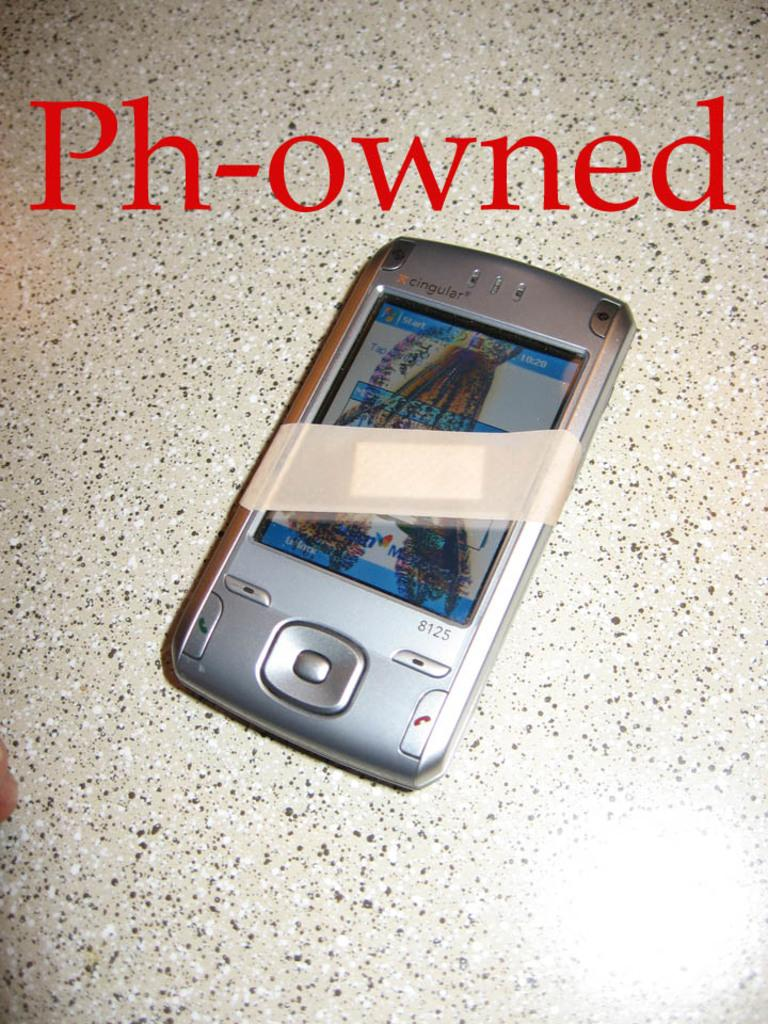<image>
Share a concise interpretation of the image provided. A phone with the words written in red Ph-owned. 